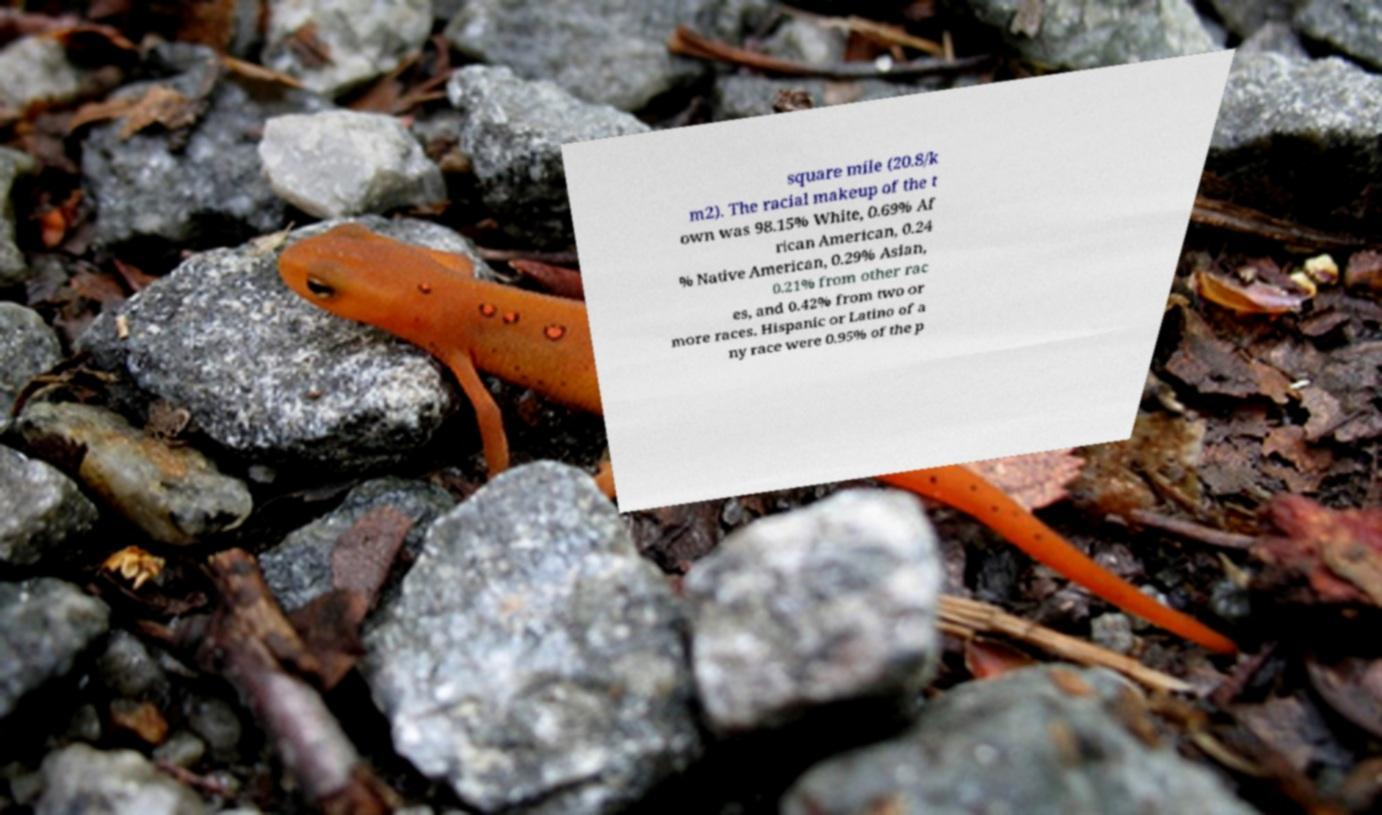For documentation purposes, I need the text within this image transcribed. Could you provide that? square mile (20.8/k m2). The racial makeup of the t own was 98.15% White, 0.69% Af rican American, 0.24 % Native American, 0.29% Asian, 0.21% from other rac es, and 0.42% from two or more races. Hispanic or Latino of a ny race were 0.95% of the p 